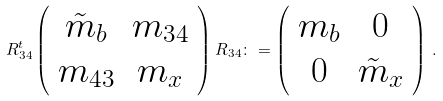Convert formula to latex. <formula><loc_0><loc_0><loc_500><loc_500>R ^ { t } _ { 3 4 } \left ( \begin{array} { c c } \tilde { m } _ { b } & m _ { 3 4 } \\ m _ { 4 3 } & m _ { x } \end{array} \right ) R _ { 3 4 } \colon = \left ( \begin{array} { c c } m _ { b } & 0 \\ 0 & \tilde { m } _ { x } \end{array} \right ) \, .</formula> 